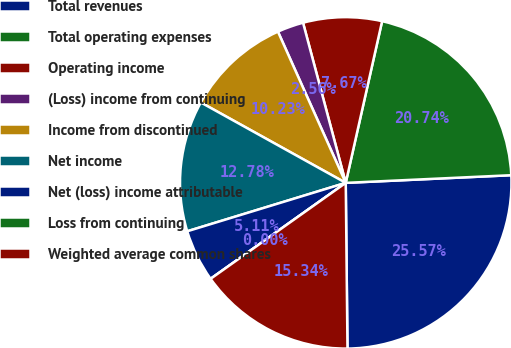Convert chart to OTSL. <chart><loc_0><loc_0><loc_500><loc_500><pie_chart><fcel>Total revenues<fcel>Total operating expenses<fcel>Operating income<fcel>(Loss) income from continuing<fcel>Income from discontinued<fcel>Net income<fcel>Net (loss) income attributable<fcel>Loss from continuing<fcel>Weighted average common shares<nl><fcel>25.57%<fcel>20.74%<fcel>7.67%<fcel>2.56%<fcel>10.23%<fcel>12.78%<fcel>5.11%<fcel>0.0%<fcel>15.34%<nl></chart> 